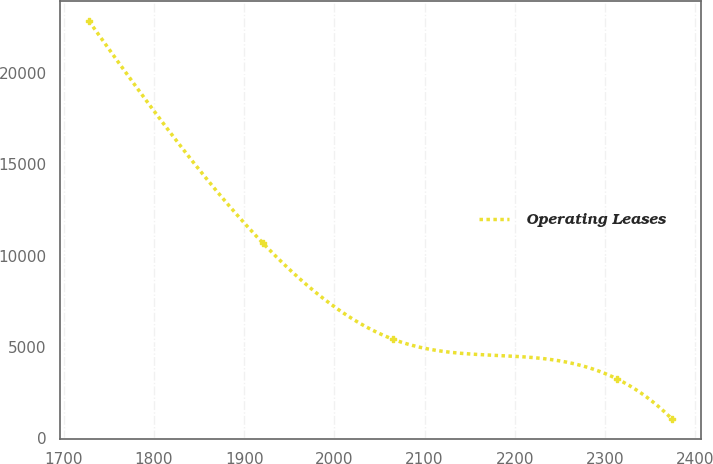<chart> <loc_0><loc_0><loc_500><loc_500><line_chart><ecel><fcel>Operating Leases<nl><fcel>1727.92<fcel>22854.1<nl><fcel>1920.41<fcel>10708.7<nl><fcel>2064.74<fcel>5428.94<nl><fcel>2313.35<fcel>3250.79<nl><fcel>2373.95<fcel>1072.64<nl></chart> 